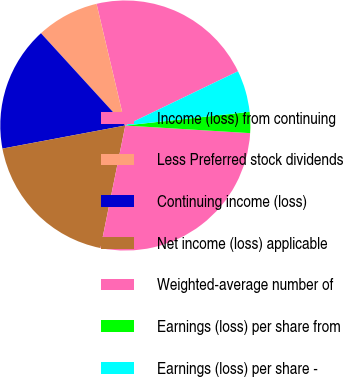Convert chart to OTSL. <chart><loc_0><loc_0><loc_500><loc_500><pie_chart><fcel>Income (loss) from continuing<fcel>Less Preferred stock dividends<fcel>Continuing income (loss)<fcel>Net income (loss) applicable<fcel>Weighted-average number of<fcel>Earnings (loss) per share from<fcel>Earnings (loss) per share -<nl><fcel>21.56%<fcel>8.09%<fcel>16.17%<fcel>18.86%<fcel>27.21%<fcel>2.71%<fcel>5.4%<nl></chart> 